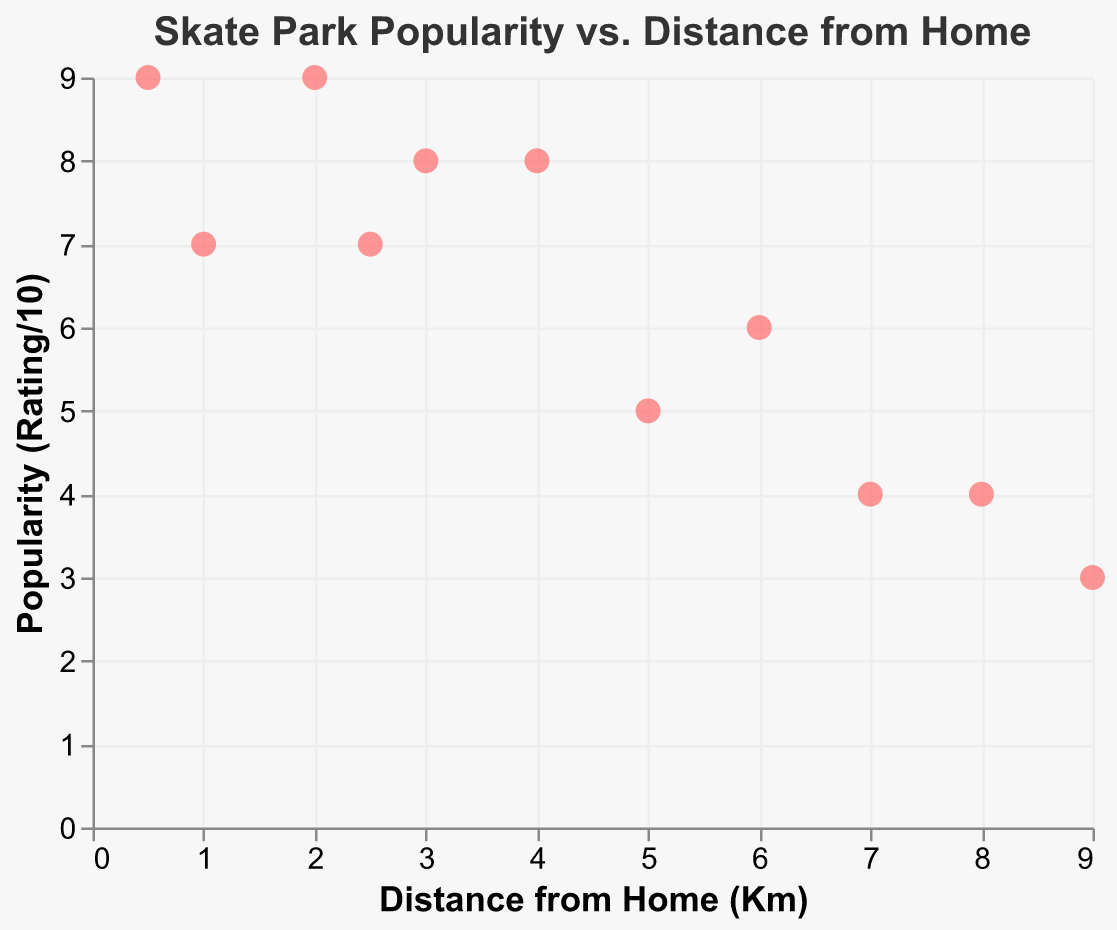How many skate parks have a popularity rating of 8 or higher? First, look at the y-axis and identify points that have a Popularity value of 8 or higher. There are Venice Beach Skate Park, Lincoln City Skate Park, Houghton Park Skate Plaza, and Alondra Park Skate Park. So, there are 4 skate parks in total.
Answer: 4 Which skate park is the farthest from home and what is its popularity rating? Look along the x-axis for the highest distance value, which is 9 km. Check the corresponding point on the y-axis to find its Popularity, which is Culver City Skate Park with a rating of 3 out of 10.
Answer: Culver City Skate Park, 3 Is there any skate park with a distance less than 1 km that has a popularity rating of less than 9? Among the skate parks with distances less than 1 km, look at Alondra Park Skate Park whose distance is 0.5 km and has a popularity rating of 9. None have a popularity rating of less than 9.
Answer: No What is the average distance from home for skate parks with a popularity rating of 7? Identify the skate parks with a rating of 7: Westchester Park (1 km) and Belvedere Skate Park (2.5 km). Calculate the average distance: (1 + 2.5) / 2 = 1.75 km.
Answer: 1.75 km Which skate park has the same distance from home but different popularity? Look for points on the x-axis that share the same distance. Venice Beach Skate Park and Belvedere Skate Park both have close distances of 2 and 2.5 km, respectively, but different popularity ratings of 9 and 7.
Answer: Venice Beach Skate Park and Belvedere Skate Park Which skate park is the closest to home and does it have the highest popularity rating? The closest is Alondra Park Skate Park at 0.5 km. Check its popularity rating which is 9. To confirm if it's the highest, compare with other values on the y-axis; only Venice Beach Skate Park matches with a rating of 9.
Answer: Yes How does the popularity of Anderson Skate Park compare to Lincoln City Skate Park? Check the y-axis for Anderson Skate Park and Lincoln City Skate Park. Anderson Skate Park has a rating of 4, and Lincoln City Skate Park has a rating of 8. Lincoln City Skate Park is more popular.
Answer: Lincoln City Skate Park is more popular On average, how does the popularity of skate parks within 5 km compare to those farther than 5 km from home? First, categorize the parks: Within 5 km: Venice Beach, Lincoln City, Westchester, Houghton, Belvedere, Alondra (9, 8, 7, 8, 7, 9); Farther than 5 km: El Sereno, Garvanza, Paramount, Culver City, Anderson (6, 5, 4, 3, 4). Calculate average for both groups: (9+8+7+8+7+9)/6 = 8; (6+5+4+3+4)/5 = 4.4.
Answer: Within 5 km: 8, Farther than 5 km: 4.4 